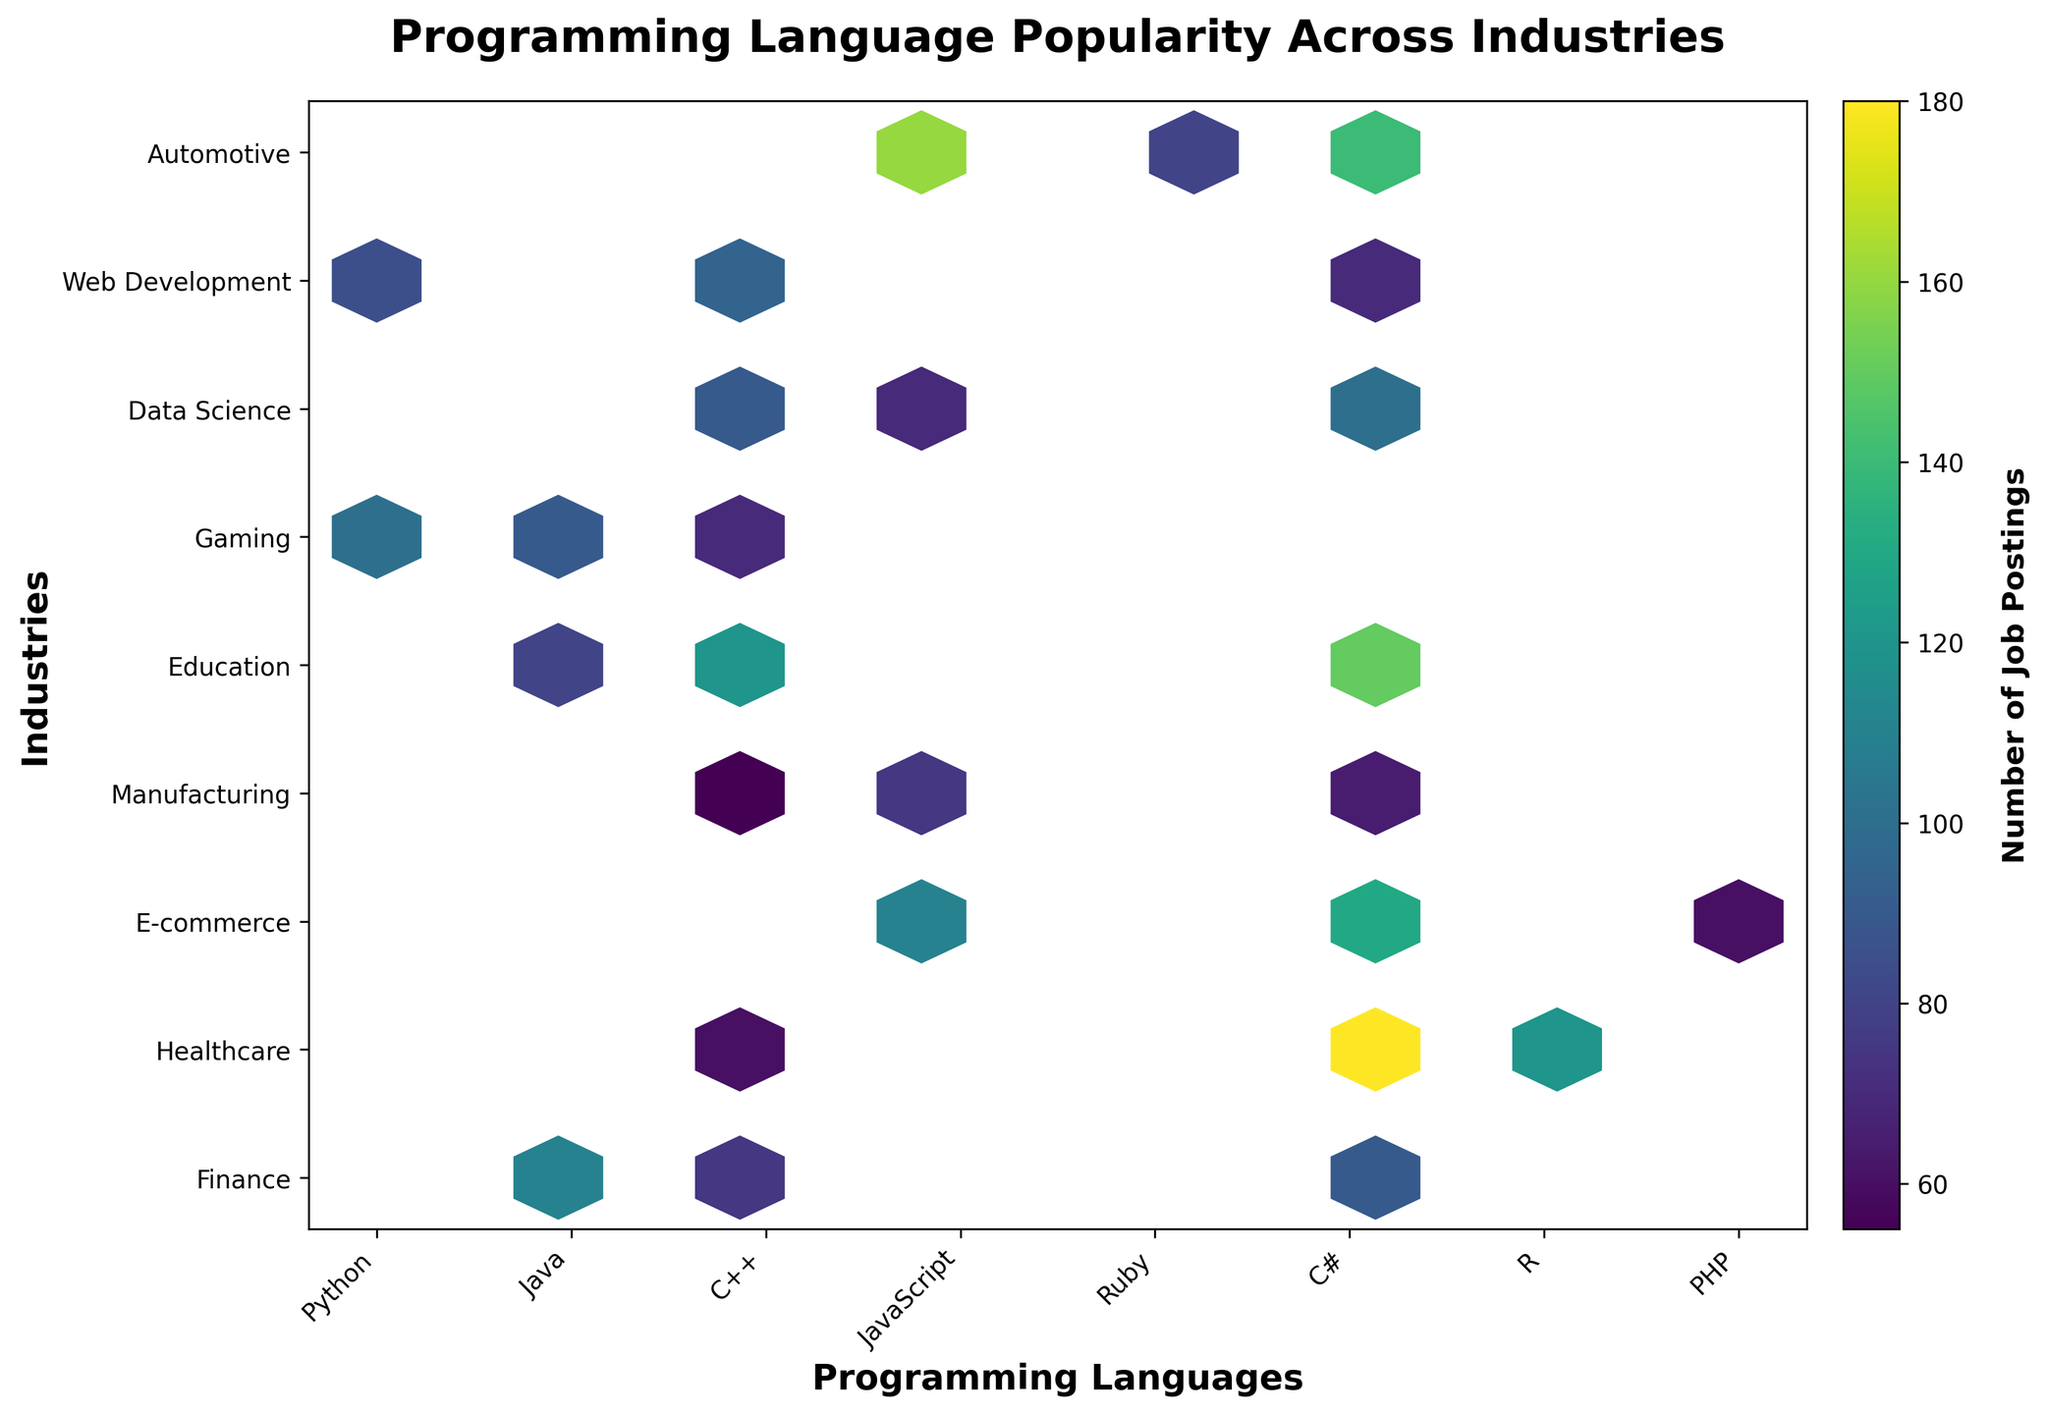What is the title of the Hexbin Plot? The title is usually placed at the top of the plot and is visually distinct due to its larger font size and bold formatting. The title for this plot is "Programming Language Popularity Across Industries".
Answer: Programming Language Popularity Across Industries Which programming language has the highest number of job postings in Data Science? Identify the hexagon with the highest color intensity in the Data Science row, then check the corresponding label in the Programming Languages column. The data shows that Python has the highest number of job postings in Data Science industry.
Answer: Python How many job postings are there for Python in Healthcare compared to JavaScript in the same industry? Locate the hexagons for Python and JavaScript within the Healthcare row. The colorbar can be used to estimate their respective numerical values. Python has 100 job postings, and JavaScript has 70 job postings in Healthcare.
Answer: Python: 100, JavaScript: 70 Is there more demand for C++ in Finance or Gaming? Compare the hexagons for C++ in the Finance and Gaming rows using color intensity. Finance row has a lighter color compared to Gaming for C++. Finance has 80 job postings, and Gaming has 90 job postings.
Answer: Gaming What is the total number of job postings for JavaScript in all industries? Sum the job postings for JavaScript across all industries by identifying the hexagons related to JavaScript and adding their values. The totals are Healthcare: 70, E-commerce: 110, Education: 75, Web Development: 160, which sums up to 415
Answer: 415 Which industry has the least number of job postings for Java? Locate all hexagons corresponding to Java across different industries and identify the one with the least color intensity. Java has the least number of job postings in the Data Science industry, with 60.
Answer: Data Science Does Automotive industry have higher demand for Python or Java? Compare the hexagons for Python and Java within the Automotive industry row. The color intensity shows Python has 90 job postings, and Java has 75 job postings in Automotive.
Answer: Python What industry has the highest total number of job postings for all programming languages combined? Sum the job postings for each programming language within every industry and identify the industry with the highest total. Web Development, with Python: 140, JavaScript: 160, and PHP: 80, has a total sum of 380.
Answer: Web Development 